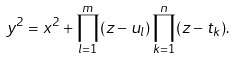<formula> <loc_0><loc_0><loc_500><loc_500>y ^ { 2 } = x ^ { 2 } + \prod _ { l = 1 } ^ { m } ( z - u _ { l } ) \prod _ { k = 1 } ^ { n } ( z - t _ { k } ) .</formula> 